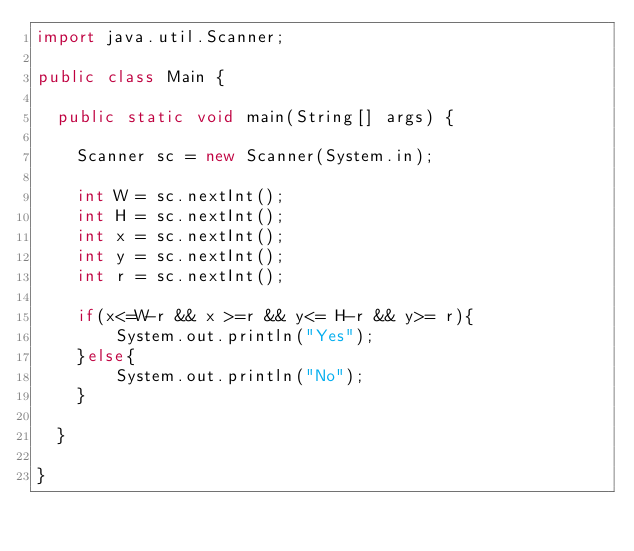<code> <loc_0><loc_0><loc_500><loc_500><_Java_>import java.util.Scanner;

public class Main {

	public static void main(String[] args) {

		Scanner sc = new Scanner(System.in);
		
		int W = sc.nextInt();
		int H = sc.nextInt();
		int x = sc.nextInt();
		int y = sc.nextInt();
		int r = sc.nextInt();
		
		if(x<=W-r && x >=r && y<= H-r && y>= r){
		    System.out.println("Yes");
		}else{
		    System.out.println("No");
		}
	    
	}
    
}
</code> 